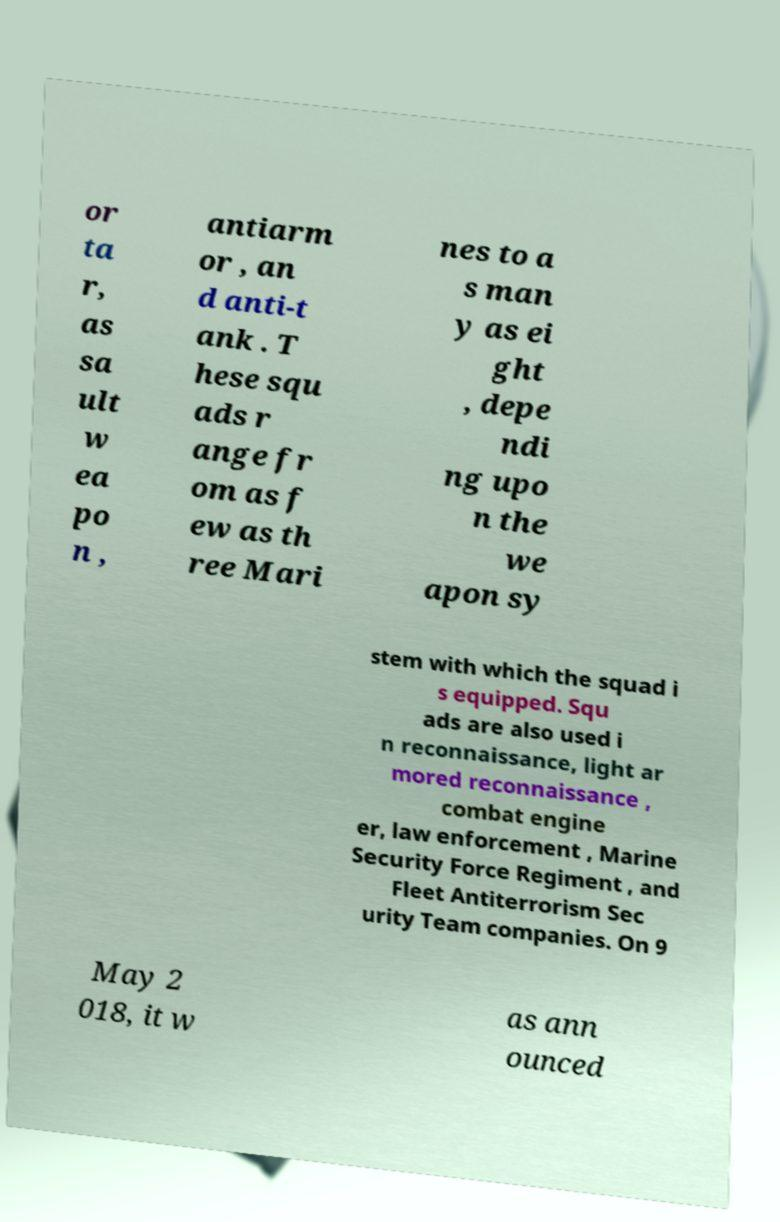There's text embedded in this image that I need extracted. Can you transcribe it verbatim? or ta r, as sa ult w ea po n , antiarm or , an d anti-t ank . T hese squ ads r ange fr om as f ew as th ree Mari nes to a s man y as ei ght , depe ndi ng upo n the we apon sy stem with which the squad i s equipped. Squ ads are also used i n reconnaissance, light ar mored reconnaissance , combat engine er, law enforcement , Marine Security Force Regiment , and Fleet Antiterrorism Sec urity Team companies. On 9 May 2 018, it w as ann ounced 